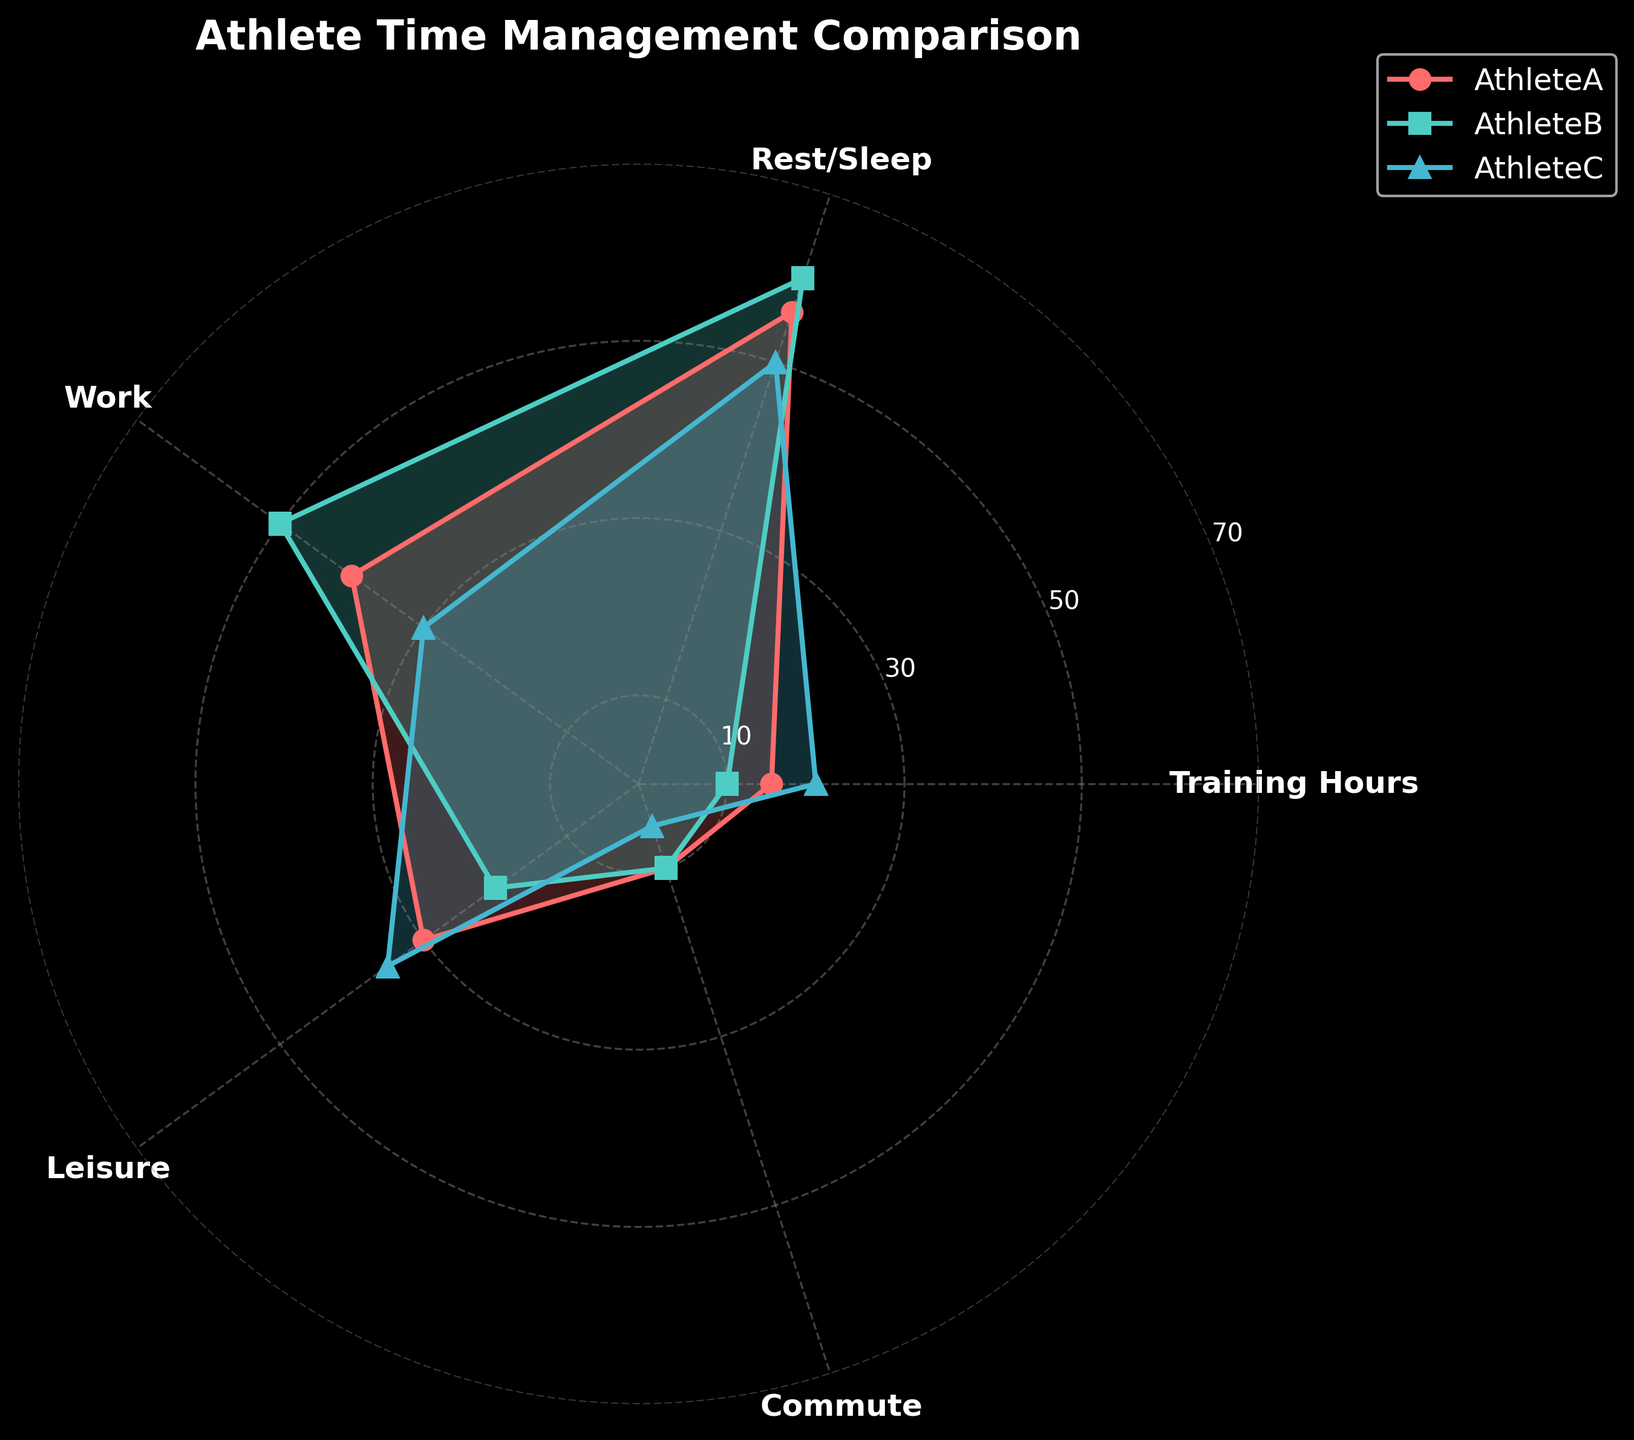How many categories are there in the radar chart? There are five categories shown on the radar chart: Training Hours, Rest/Sleep, Work, Leisure, and Commute. You can count the labels around the radar chart to determine this.
Answer: 5 Which athlete spends the most hours training? To find this, look for the highest value in the Training Hours category on the radar chart. Athlete C has the highest Training Hours at 20.
Answer: Athlete C What is the sum of work and leisure hours for Athlete B? Athlete B spends 50 hours on Work and 20 hours on Leisure. Adding these together gives 50 + 20 = 70 hours.
Answer: 70 hours Which category has the highest average time spent across all athletes? Calculate the average hours for each category. Training Hours: (15+10+20)/3 = 15, Rest/Sleep: (56+60+50)/3 ≈ 55.33, Work: (40+50+30)/3 ≈ 40, Leisure: (30+20+35)/3 ≈ 28.33, Commute: (10+10+5)/3 ≈ 8.33. Rest/Sleep has the highest average at approximately 55.33 hours.
Answer: Rest/Sleep Between Athlete A and Athlete B, who spends less time commuting? Check the values in the Commute category for Athlete A and Athlete B. Both Athlete A and Athlete B spend 10 hours commuting, so they spend the same amount of time.
Answer: Same amount How do the training hours of Athlete A compare to the leisure hours of Athlete A? Athlete A spends 15 hours on Training and 30 hours on Leisure, so Athlete A spends more time on Leisure by 30 - 15 = 15 hours.
Answer: Athlete A spends more time on Leisure What is the total number of rest/sleep hours of all three athletes combined? Sum up the Rest/Sleep hours of Athlete A, Athlete B, and Athlete C: 56 + 60 + 50 = 166 hours.
Answer: 166 hours Which athlete has the least variation in their time spent across all categories? Check the spread of values for each athlete across the categories. Athlete B's values (10, 60, 50, 20, 10) seem less varied compared to Athlete A (15, 56, 40, 30, 10) and Athlete C (20, 50, 30, 35, 5). Therefore, Athlete B has the least variation.
Answer: Athlete B 